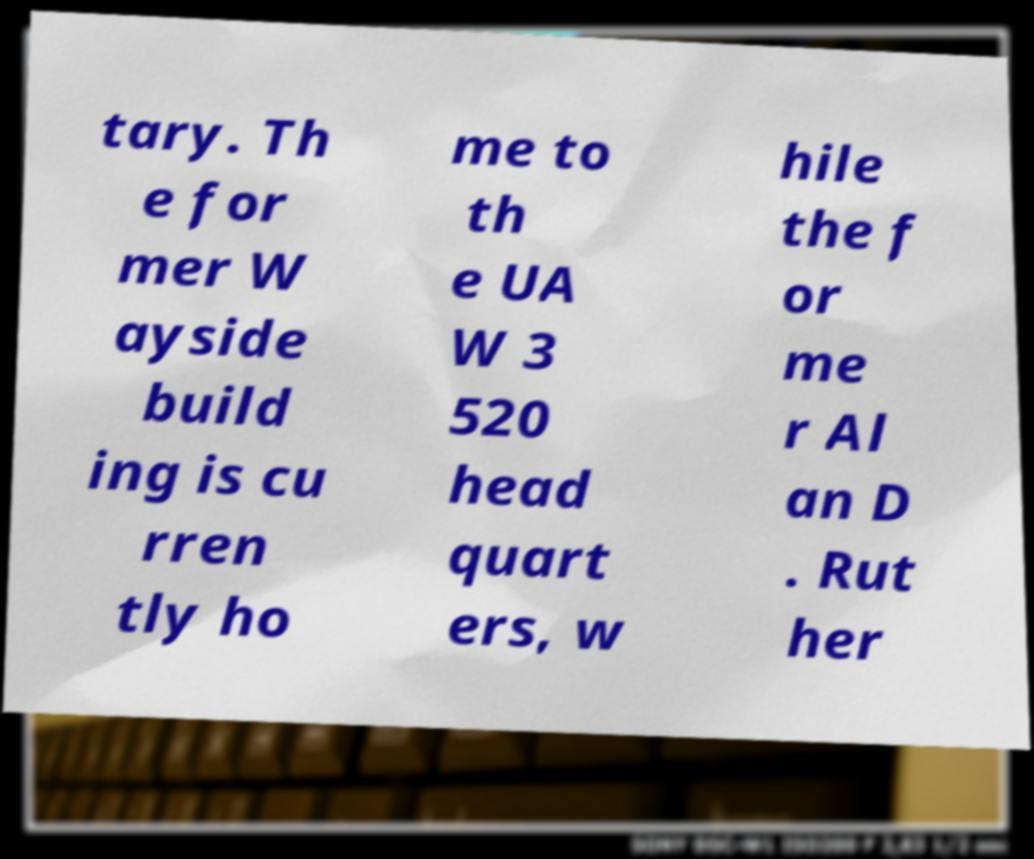Could you extract and type out the text from this image? tary. Th e for mer W ayside build ing is cu rren tly ho me to th e UA W 3 520 head quart ers, w hile the f or me r Al an D . Rut her 